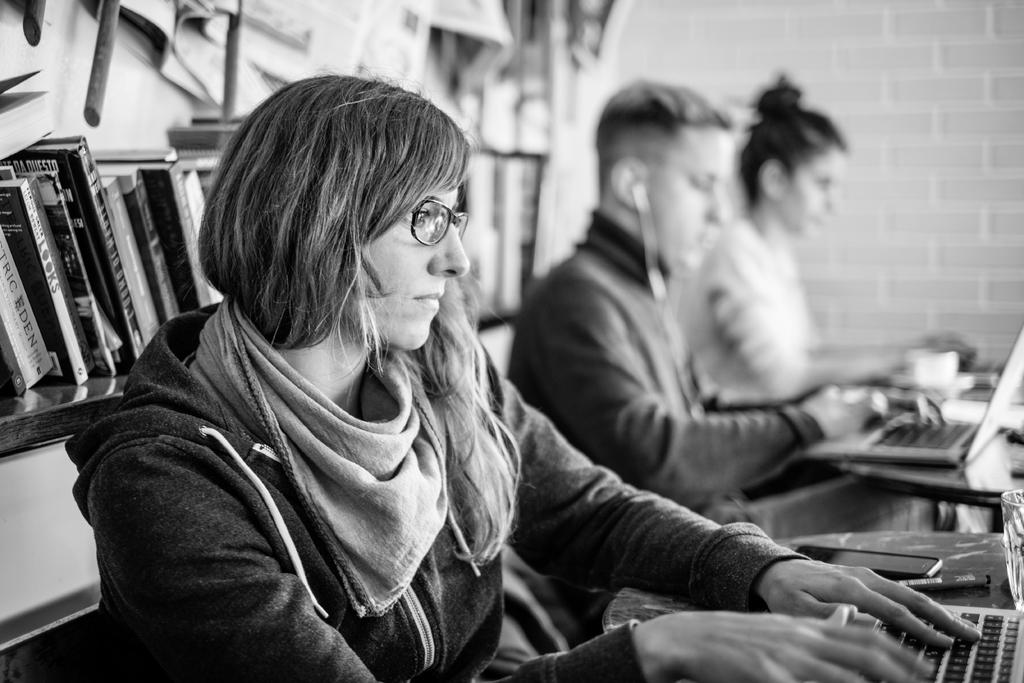What is the last word of the second book?
Provide a short and direct response. Looks. 